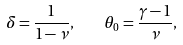<formula> <loc_0><loc_0><loc_500><loc_500>\delta = \frac { 1 } { 1 - \nu } , \quad \theta _ { 0 } = \frac { \gamma - 1 } { \nu } ,</formula> 